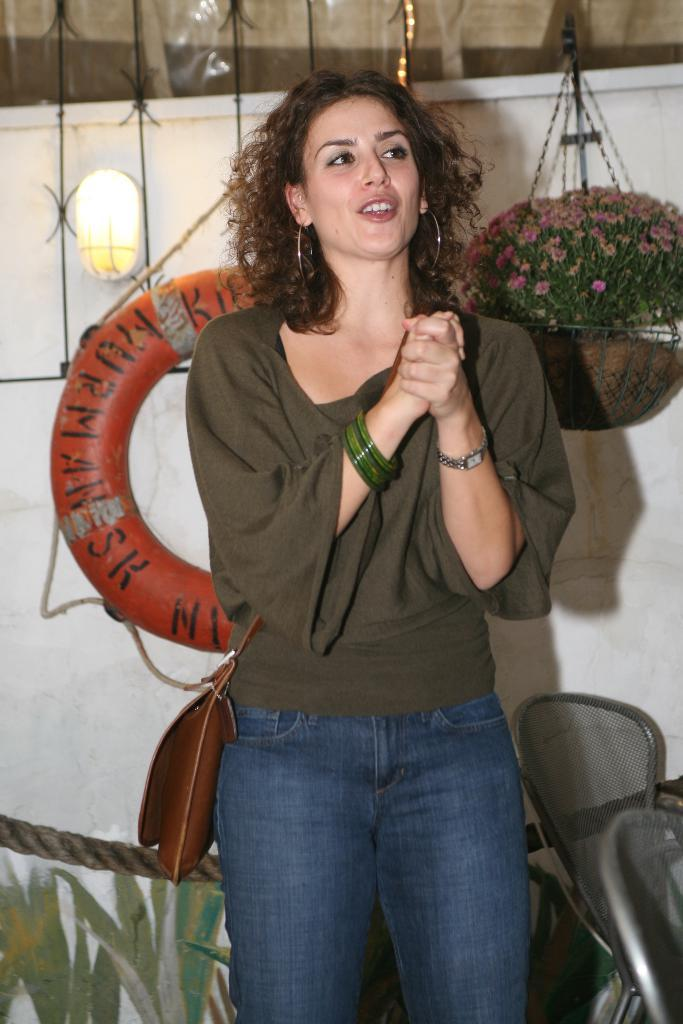What is the main subject of the image? There is a woman standing in the image. What is the woman doing in the image? The woman is looking at someone. What can be seen in the background of the image? There is a tube, a light, and a hanging flower pot in the background of the image. What hobbies does the cat have, as depicted in the image? There is no cat present in the image, so it is not possible to determine any hobbies. 